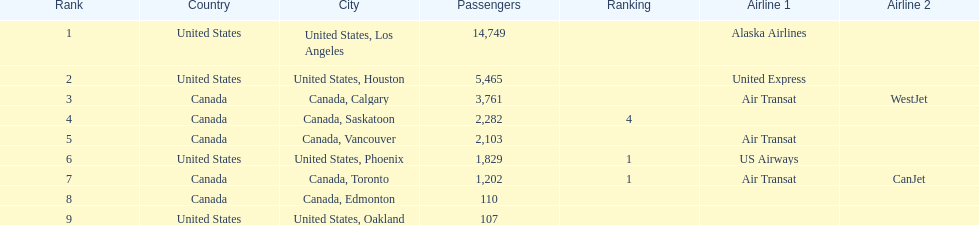The least number of passengers came from which city United States, Oakland. 